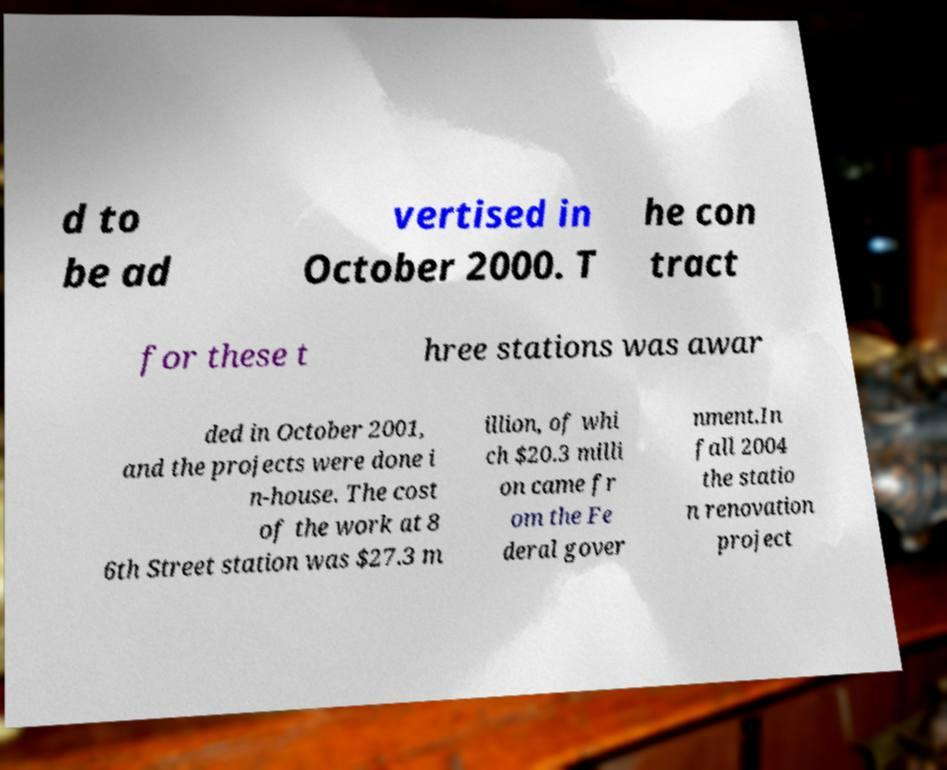Can you read and provide the text displayed in the image?This photo seems to have some interesting text. Can you extract and type it out for me? d to be ad vertised in October 2000. T he con tract for these t hree stations was awar ded in October 2001, and the projects were done i n-house. The cost of the work at 8 6th Street station was $27.3 m illion, of whi ch $20.3 milli on came fr om the Fe deral gover nment.In fall 2004 the statio n renovation project 